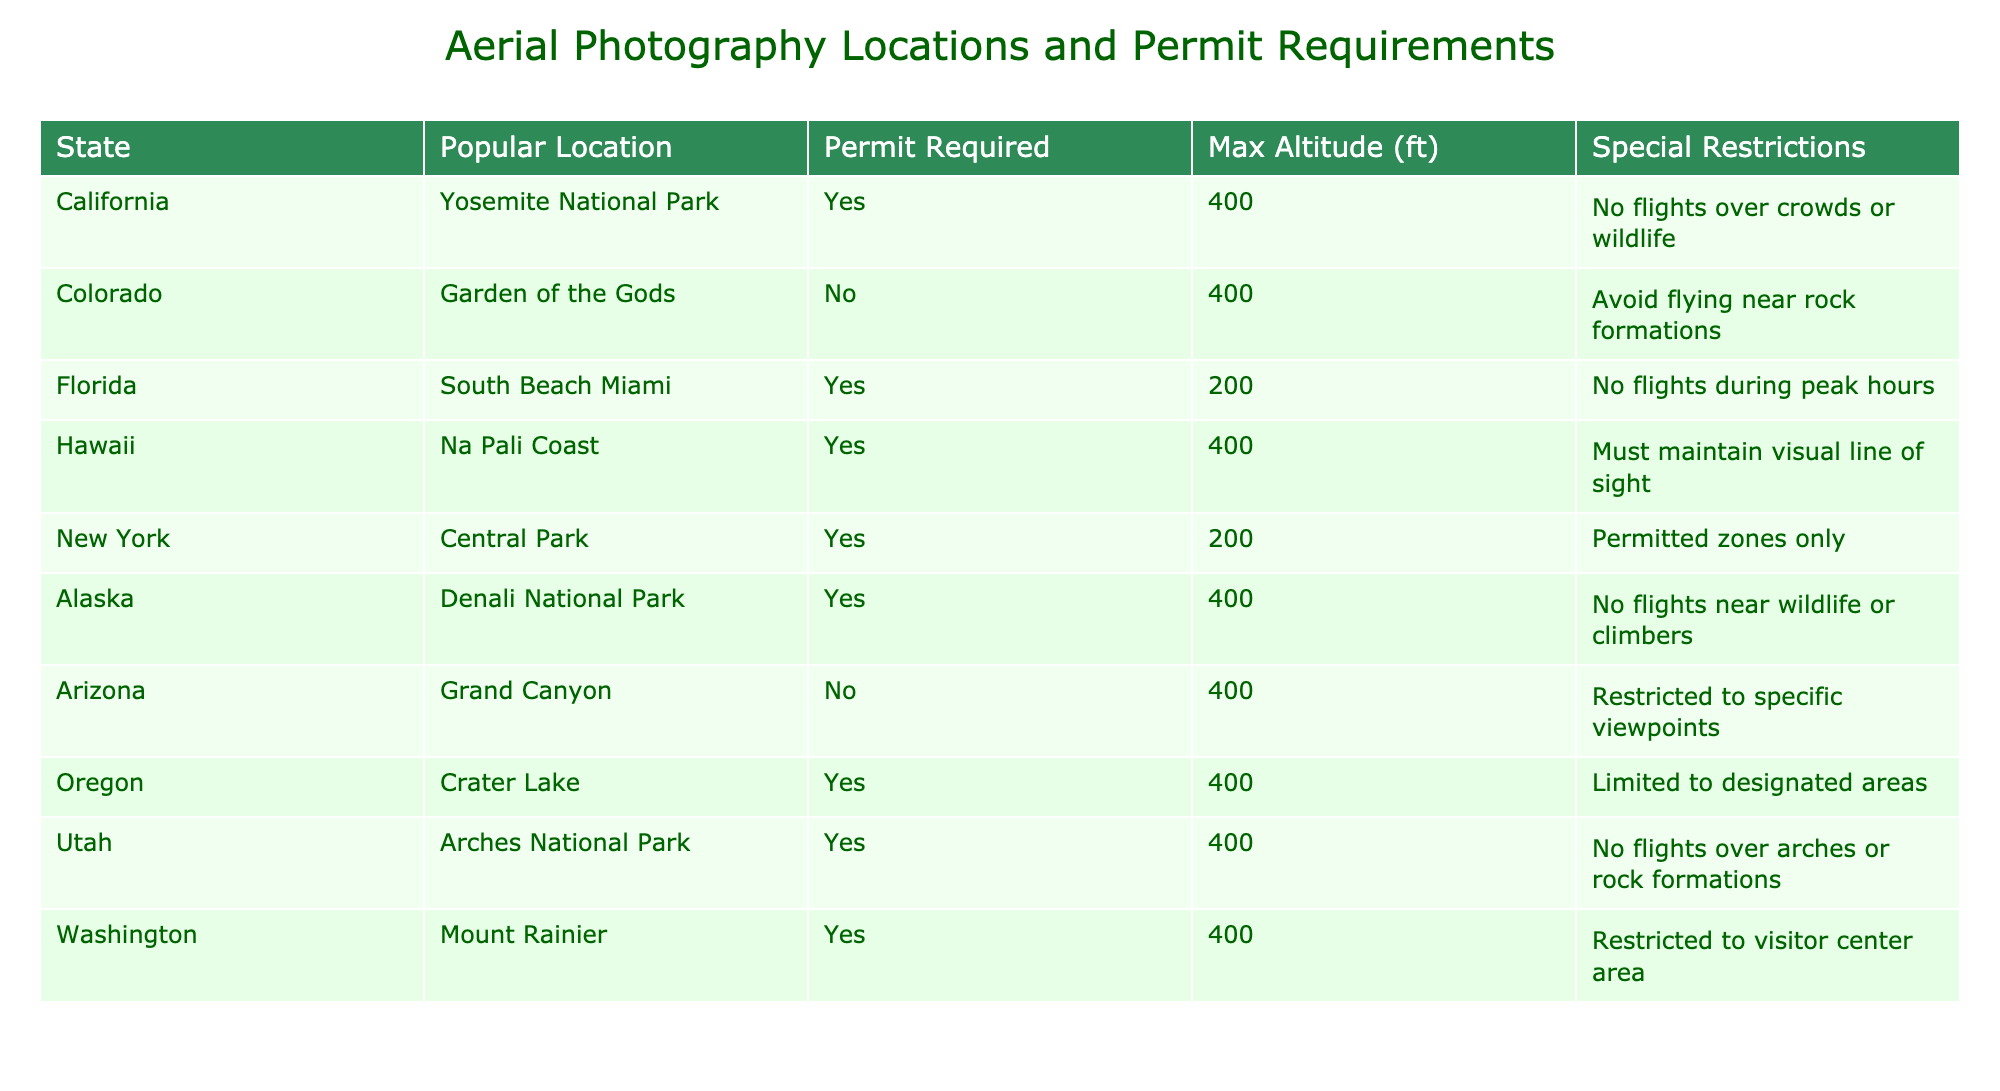What is the maximum altitude allowed for aerial photography in Florida? The table indicates the maximum altitude for Florida, which is listed as 200 feet.
Answer: 200 ft Does Garden of the Gods in Colorado require a permit for aerial photography? The table shows that a permit is not required for Garden of the Gods, as indicated in the "Permit Required" column.
Answer: No How many locations require permits for aerial photography? By reviewing the "Permit Required" column, we can see that 6 out of the 10 locations require permits (Yosemite, South Beach, Na Pali Coast, Central Park, Denali, Crater Lake, Arches, Mount Rainier), resulting in a total of 6.
Answer: 6 What is the special restriction for flights over crowds or wildlife in California? California's special restriction states "No flights over crowds or wildlife," which means that no aerial photography can occur in those scenarios to ensure safety and compliance.
Answer: No flights over crowds or wildlife What is the total number of locations listed in the table that allow flying at an altitude of 400 feet? From the table, six locations (Yosemite, Garden of the Gods, Denali, Grand Canyon, Crater Lake, Arches, Mount Rainier) are permitted to fly at 400 feet. Since we are interested in those that are specifically at 400 feet, we count them: Yosemite, Denali, Arches, Crater Lake, Mount Rainier, which totals to five distinct locations allowing for this altitude.
Answer: 6 